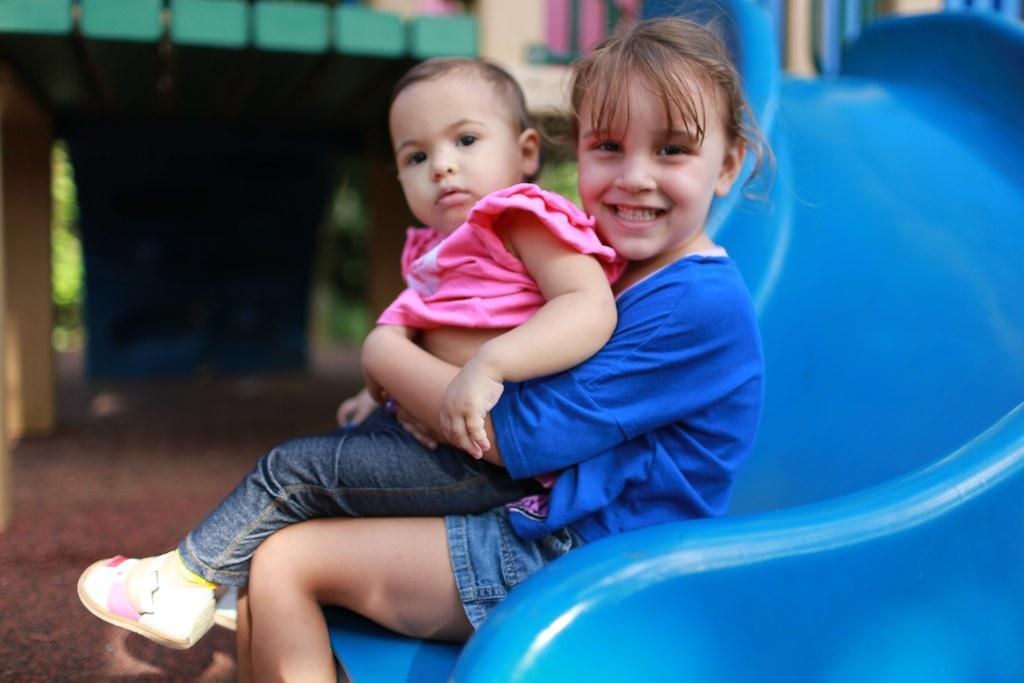In one or two sentences, can you explain what this image depicts? In this image I can see two children where one is wearing pink dress and another one is wearing blue. I can also see smile on her face and in background I can see blue colour slide. I can also see this image is little bit blurry from background. 